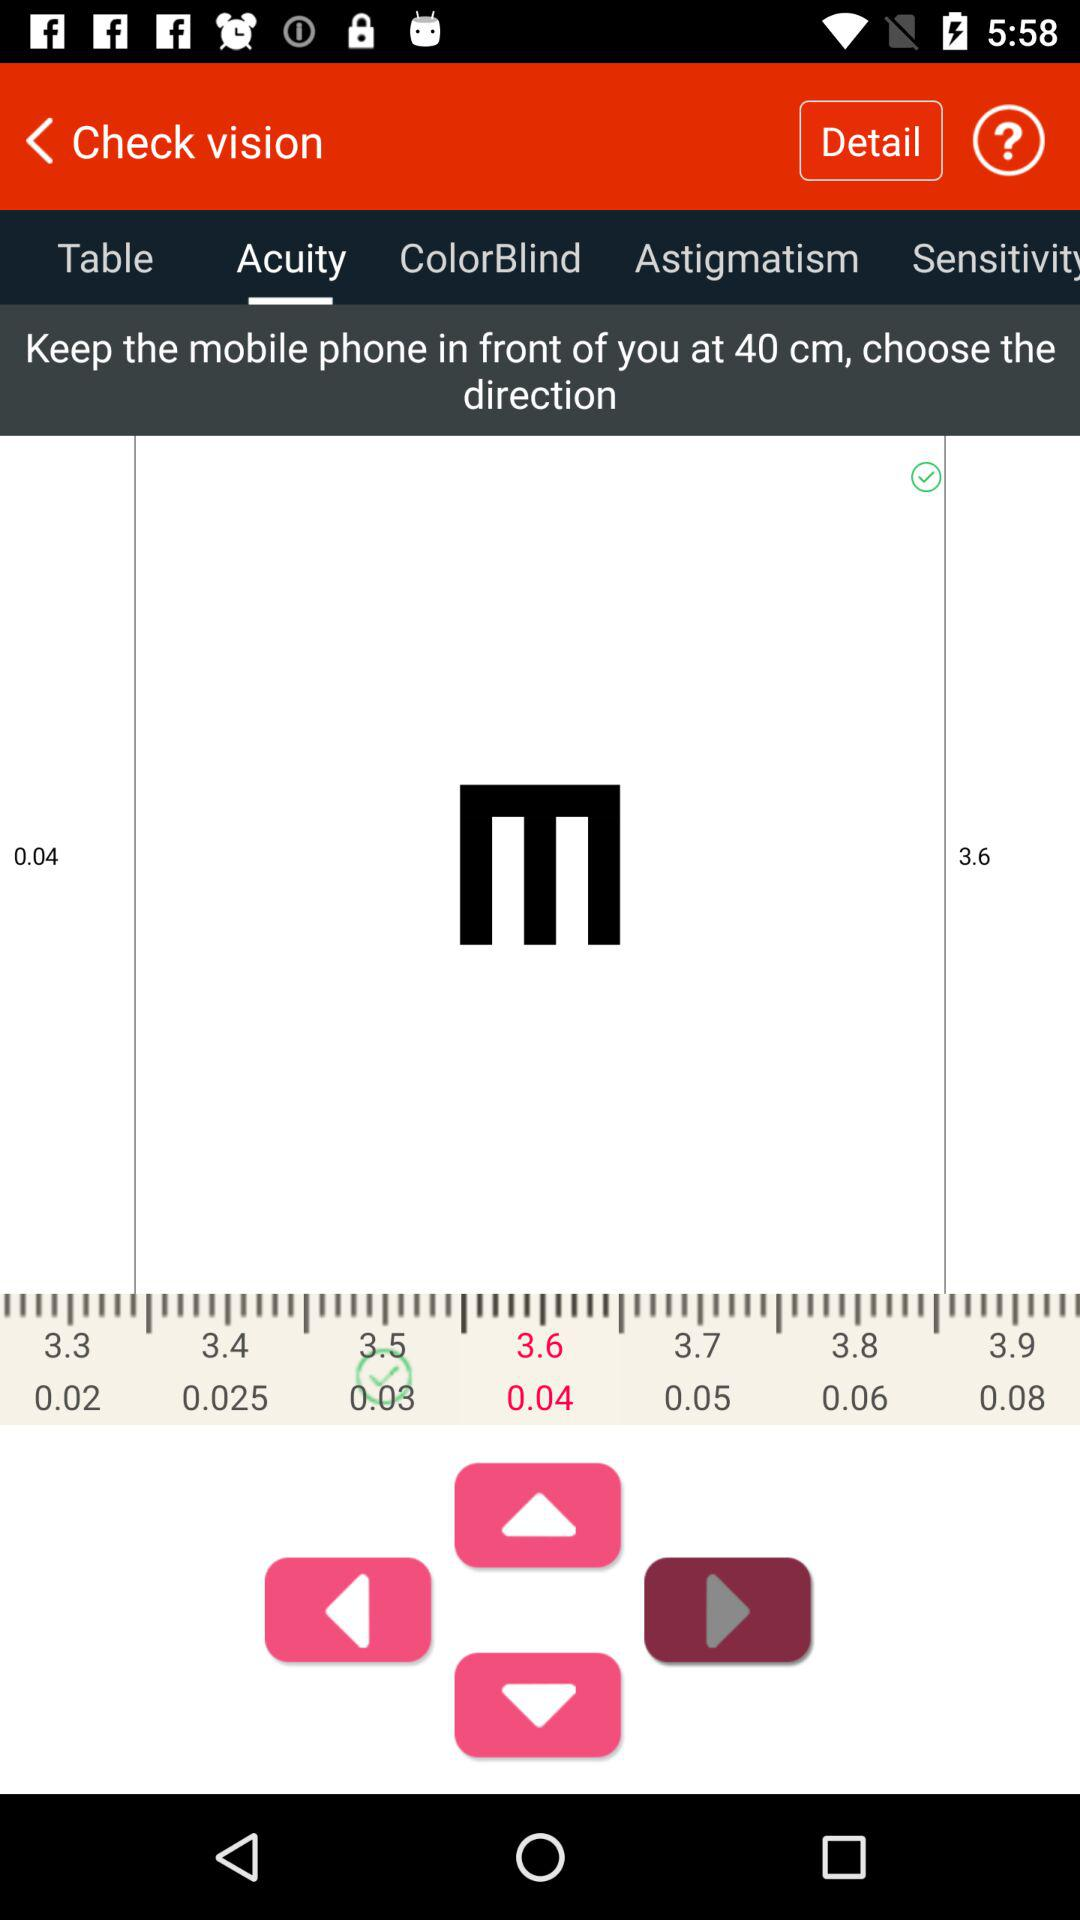How many centimetres does the mobile need to be held? The mobile needs to be held at 40 cm. 